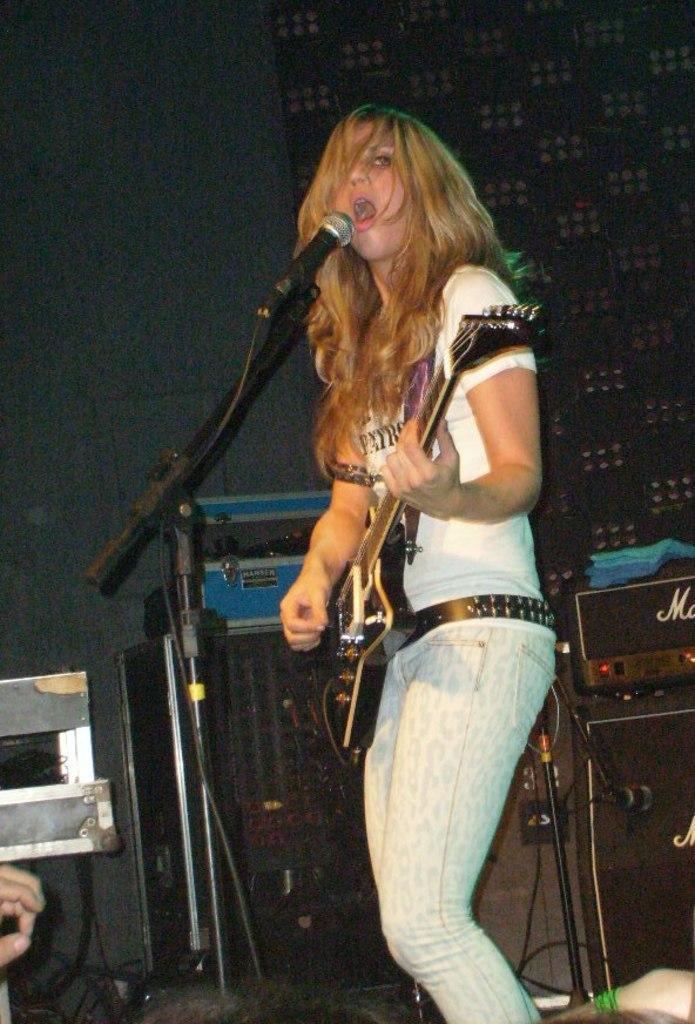Please provide a concise description of this image. In this image we have a woman who is playing a guitar and singing a song in front of the microphone. Behind the girl we can see a music system. 